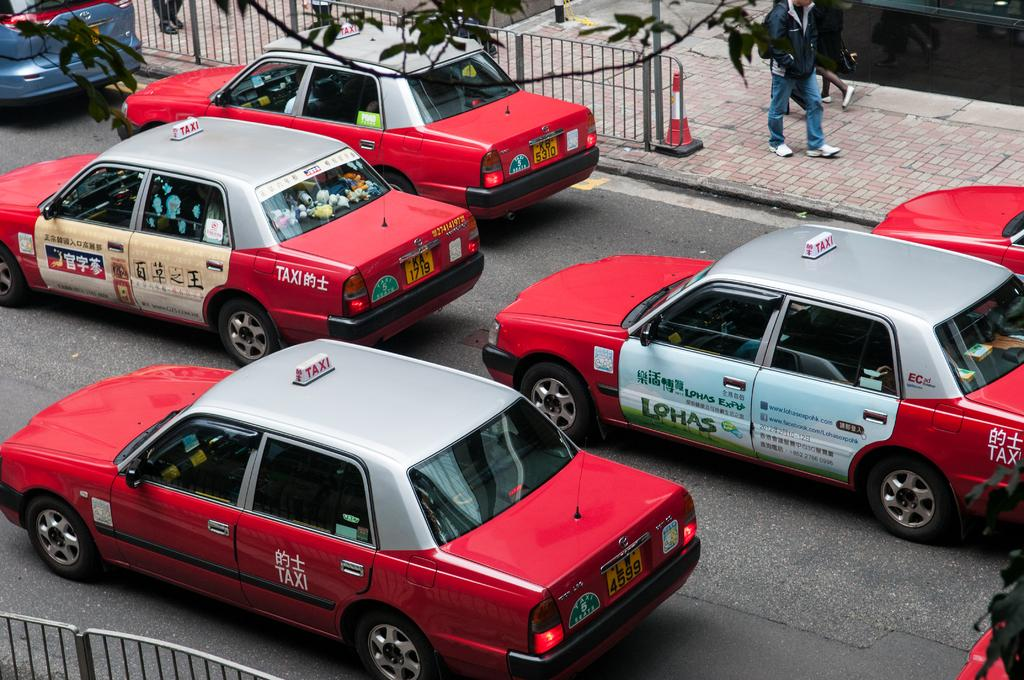Provide a one-sentence caption for the provided image. a Lohas sign that is on the side of a car. 